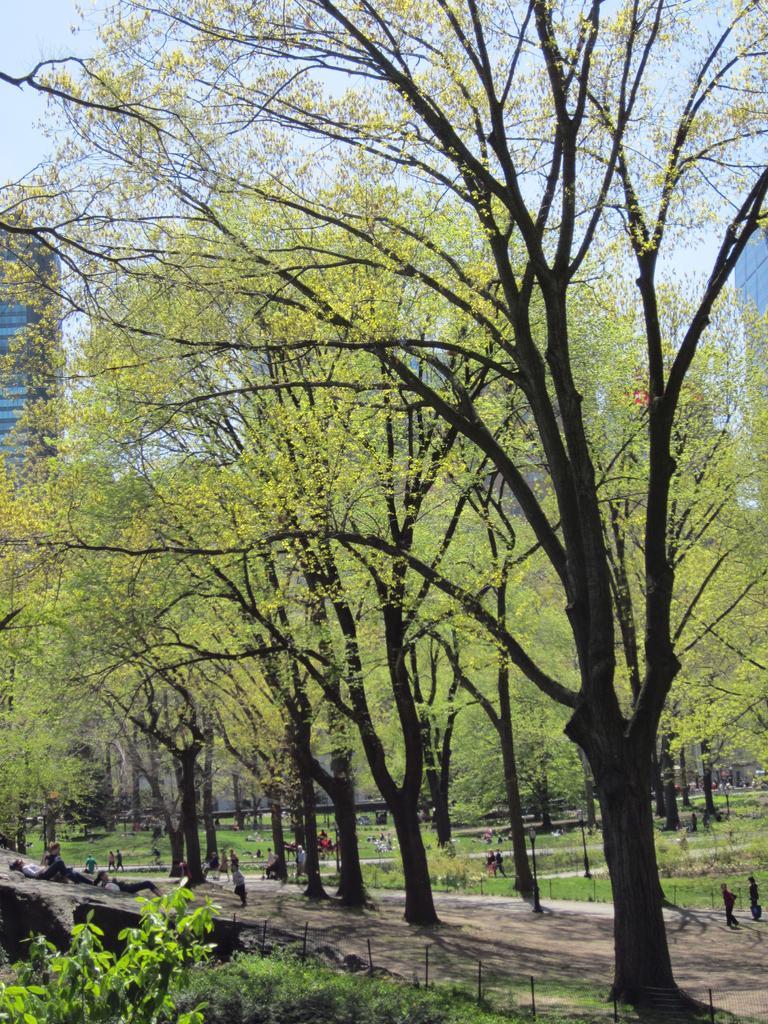Please provide a concise description of this image. In the picture I can see trees, people, fence, plants, the grass and some other objects on the ground. In the background I can see buildings and the sky. 